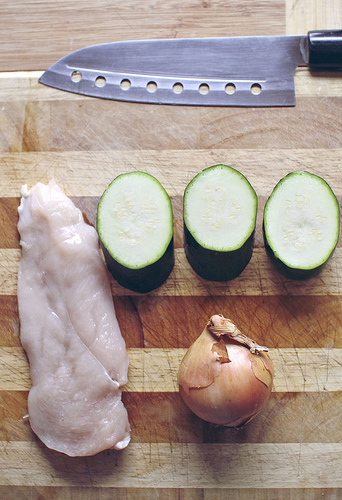<image>
Is there a knife on the onion? No. The knife is not positioned on the onion. They may be near each other, but the knife is not supported by or resting on top of the onion. Is the onion to the left of the knife? No. The onion is not to the left of the knife. From this viewpoint, they have a different horizontal relationship. 